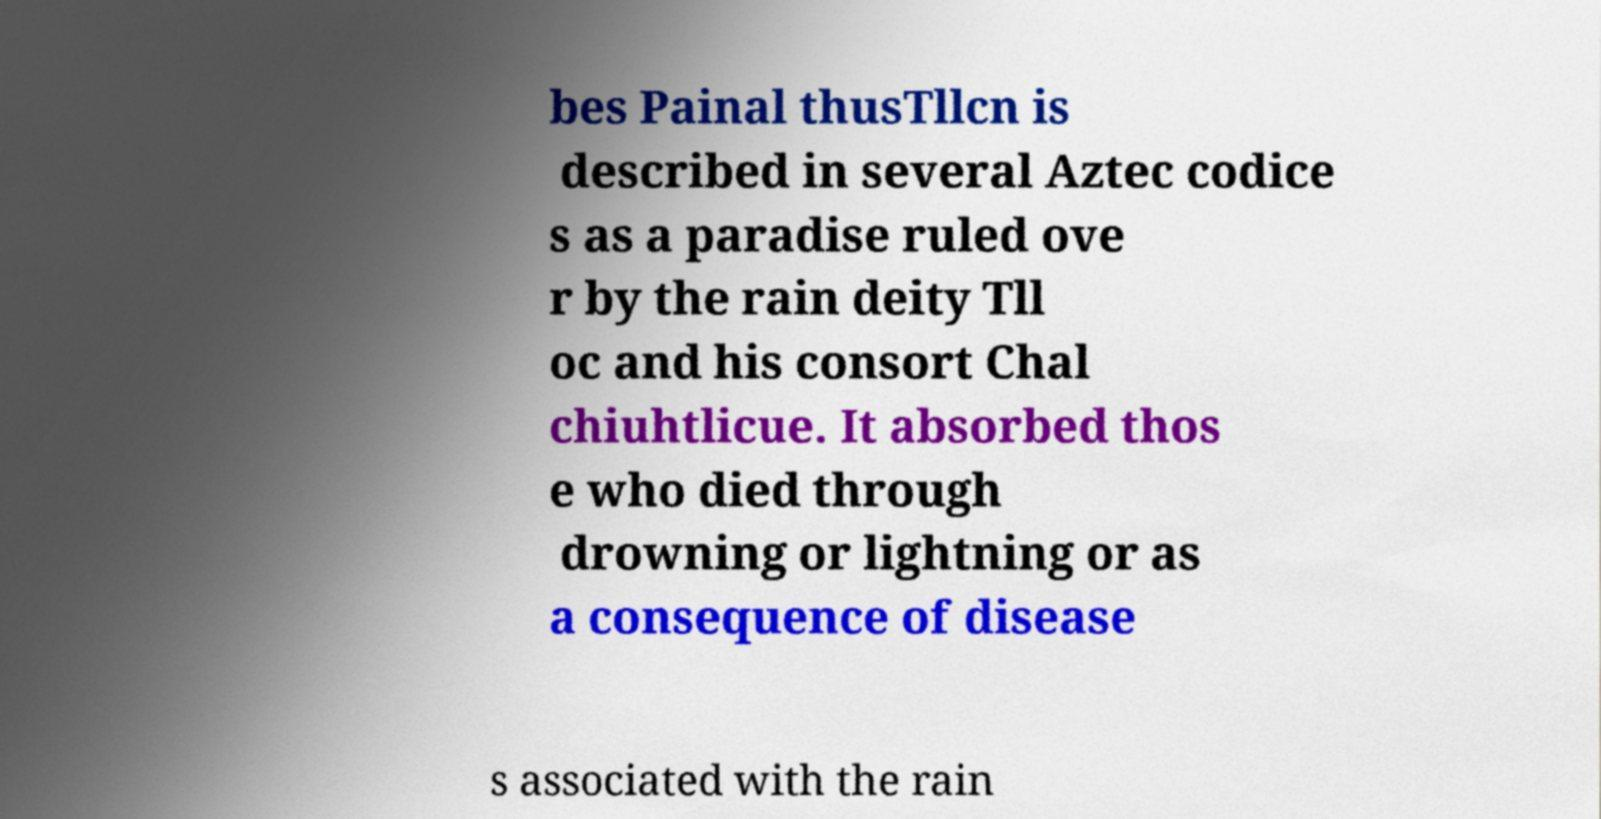Can you read and provide the text displayed in the image?This photo seems to have some interesting text. Can you extract and type it out for me? bes Painal thusTllcn is described in several Aztec codice s as a paradise ruled ove r by the rain deity Tll oc and his consort Chal chiuhtlicue. It absorbed thos e who died through drowning or lightning or as a consequence of disease s associated with the rain 